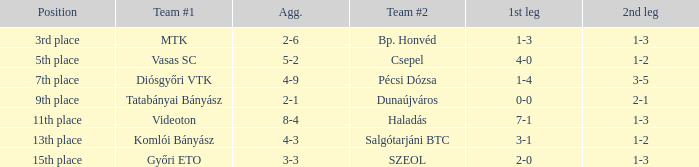What is the 1st leg with a 4-3 agg.? 3-1. 